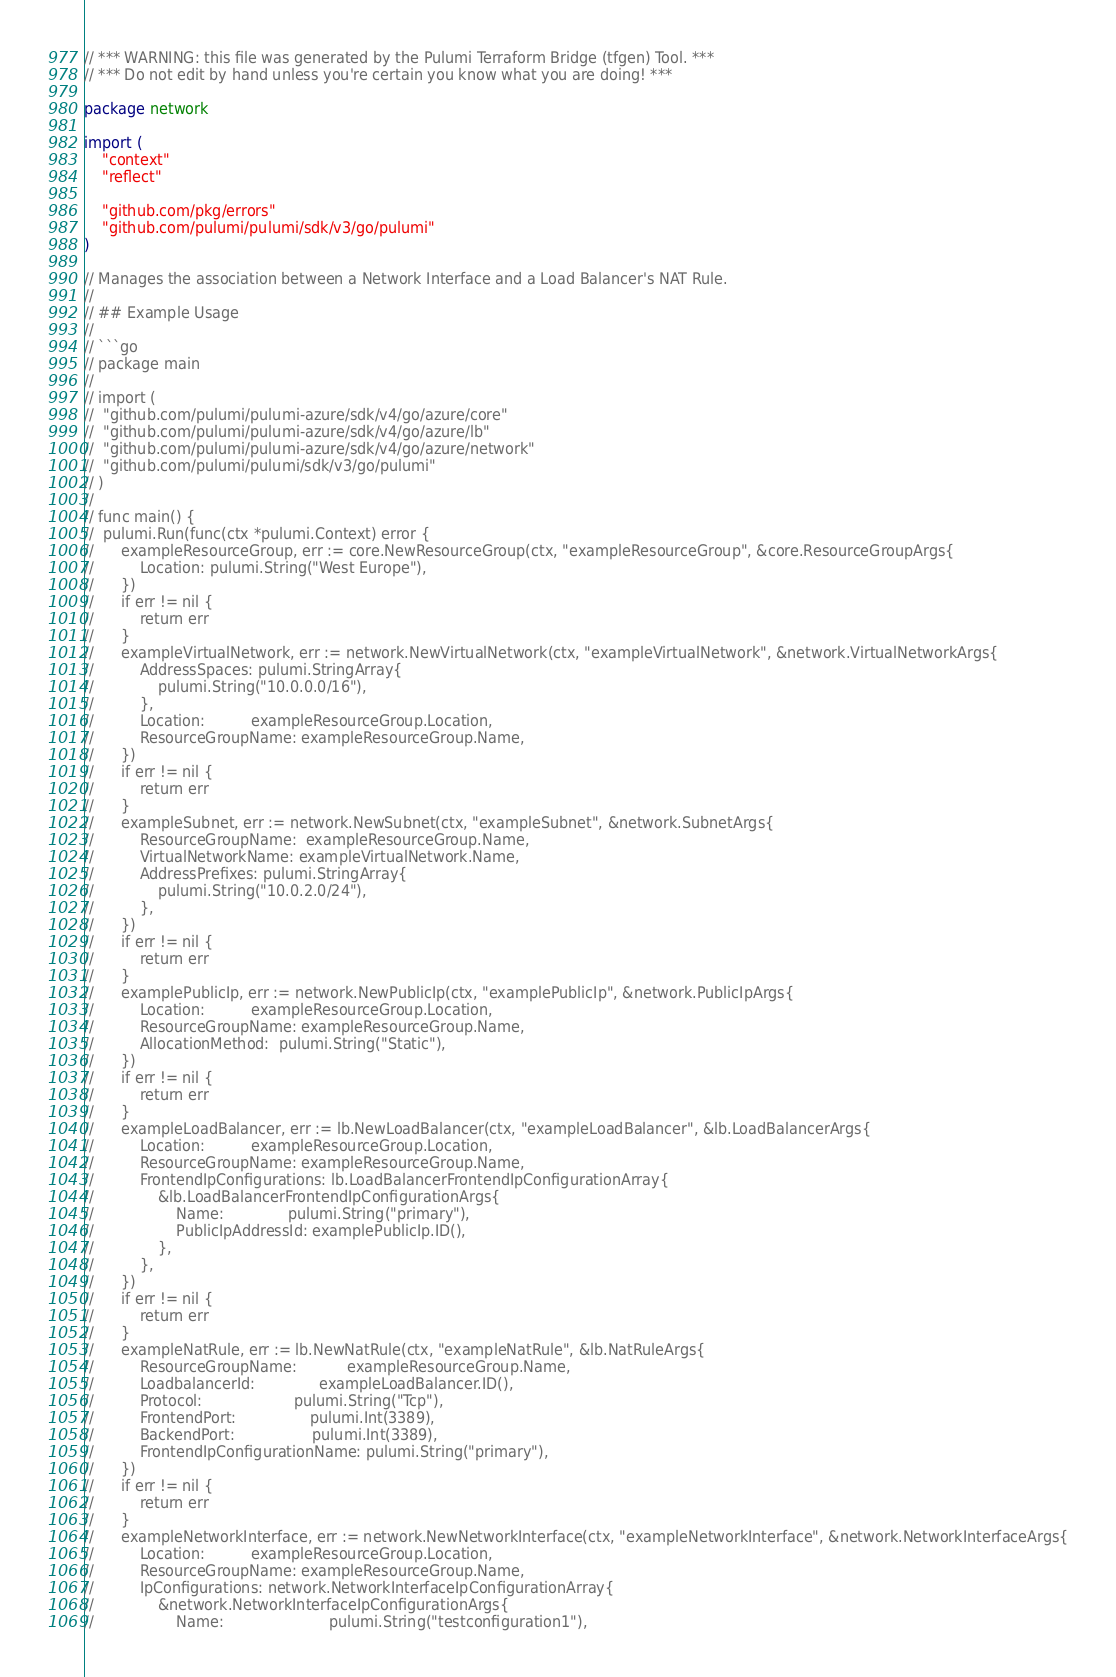<code> <loc_0><loc_0><loc_500><loc_500><_Go_>// *** WARNING: this file was generated by the Pulumi Terraform Bridge (tfgen) Tool. ***
// *** Do not edit by hand unless you're certain you know what you are doing! ***

package network

import (
	"context"
	"reflect"

	"github.com/pkg/errors"
	"github.com/pulumi/pulumi/sdk/v3/go/pulumi"
)

// Manages the association between a Network Interface and a Load Balancer's NAT Rule.
//
// ## Example Usage
//
// ```go
// package main
//
// import (
// 	"github.com/pulumi/pulumi-azure/sdk/v4/go/azure/core"
// 	"github.com/pulumi/pulumi-azure/sdk/v4/go/azure/lb"
// 	"github.com/pulumi/pulumi-azure/sdk/v4/go/azure/network"
// 	"github.com/pulumi/pulumi/sdk/v3/go/pulumi"
// )
//
// func main() {
// 	pulumi.Run(func(ctx *pulumi.Context) error {
// 		exampleResourceGroup, err := core.NewResourceGroup(ctx, "exampleResourceGroup", &core.ResourceGroupArgs{
// 			Location: pulumi.String("West Europe"),
// 		})
// 		if err != nil {
// 			return err
// 		}
// 		exampleVirtualNetwork, err := network.NewVirtualNetwork(ctx, "exampleVirtualNetwork", &network.VirtualNetworkArgs{
// 			AddressSpaces: pulumi.StringArray{
// 				pulumi.String("10.0.0.0/16"),
// 			},
// 			Location:          exampleResourceGroup.Location,
// 			ResourceGroupName: exampleResourceGroup.Name,
// 		})
// 		if err != nil {
// 			return err
// 		}
// 		exampleSubnet, err := network.NewSubnet(ctx, "exampleSubnet", &network.SubnetArgs{
// 			ResourceGroupName:  exampleResourceGroup.Name,
// 			VirtualNetworkName: exampleVirtualNetwork.Name,
// 			AddressPrefixes: pulumi.StringArray{
// 				pulumi.String("10.0.2.0/24"),
// 			},
// 		})
// 		if err != nil {
// 			return err
// 		}
// 		examplePublicIp, err := network.NewPublicIp(ctx, "examplePublicIp", &network.PublicIpArgs{
// 			Location:          exampleResourceGroup.Location,
// 			ResourceGroupName: exampleResourceGroup.Name,
// 			AllocationMethod:  pulumi.String("Static"),
// 		})
// 		if err != nil {
// 			return err
// 		}
// 		exampleLoadBalancer, err := lb.NewLoadBalancer(ctx, "exampleLoadBalancer", &lb.LoadBalancerArgs{
// 			Location:          exampleResourceGroup.Location,
// 			ResourceGroupName: exampleResourceGroup.Name,
// 			FrontendIpConfigurations: lb.LoadBalancerFrontendIpConfigurationArray{
// 				&lb.LoadBalancerFrontendIpConfigurationArgs{
// 					Name:              pulumi.String("primary"),
// 					PublicIpAddressId: examplePublicIp.ID(),
// 				},
// 			},
// 		})
// 		if err != nil {
// 			return err
// 		}
// 		exampleNatRule, err := lb.NewNatRule(ctx, "exampleNatRule", &lb.NatRuleArgs{
// 			ResourceGroupName:           exampleResourceGroup.Name,
// 			LoadbalancerId:              exampleLoadBalancer.ID(),
// 			Protocol:                    pulumi.String("Tcp"),
// 			FrontendPort:                pulumi.Int(3389),
// 			BackendPort:                 pulumi.Int(3389),
// 			FrontendIpConfigurationName: pulumi.String("primary"),
// 		})
// 		if err != nil {
// 			return err
// 		}
// 		exampleNetworkInterface, err := network.NewNetworkInterface(ctx, "exampleNetworkInterface", &network.NetworkInterfaceArgs{
// 			Location:          exampleResourceGroup.Location,
// 			ResourceGroupName: exampleResourceGroup.Name,
// 			IpConfigurations: network.NetworkInterfaceIpConfigurationArray{
// 				&network.NetworkInterfaceIpConfigurationArgs{
// 					Name:                       pulumi.String("testconfiguration1"),</code> 